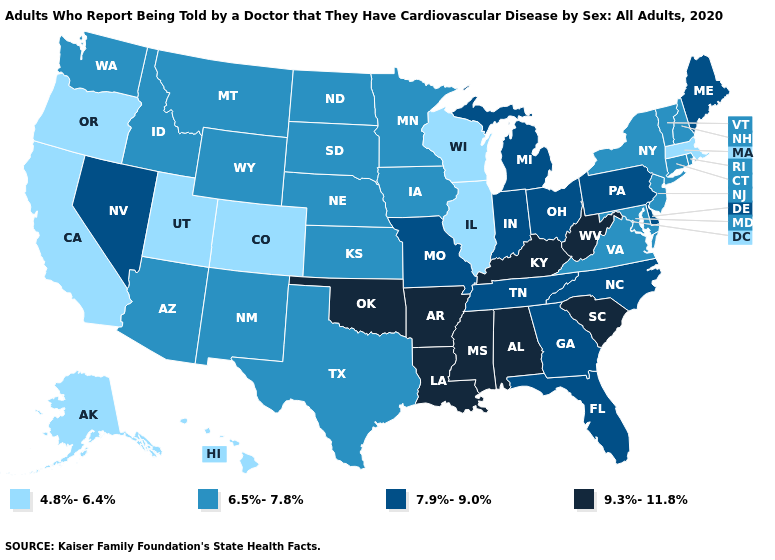What is the value of Delaware?
Write a very short answer. 7.9%-9.0%. Which states hav the highest value in the Northeast?
Write a very short answer. Maine, Pennsylvania. Does Delaware have the same value as Georgia?
Give a very brief answer. Yes. Does the first symbol in the legend represent the smallest category?
Give a very brief answer. Yes. Name the states that have a value in the range 7.9%-9.0%?
Answer briefly. Delaware, Florida, Georgia, Indiana, Maine, Michigan, Missouri, Nevada, North Carolina, Ohio, Pennsylvania, Tennessee. Name the states that have a value in the range 6.5%-7.8%?
Write a very short answer. Arizona, Connecticut, Idaho, Iowa, Kansas, Maryland, Minnesota, Montana, Nebraska, New Hampshire, New Jersey, New Mexico, New York, North Dakota, Rhode Island, South Dakota, Texas, Vermont, Virginia, Washington, Wyoming. Which states have the lowest value in the USA?
Quick response, please. Alaska, California, Colorado, Hawaii, Illinois, Massachusetts, Oregon, Utah, Wisconsin. Does Maine have the same value as New Jersey?
Answer briefly. No. Name the states that have a value in the range 9.3%-11.8%?
Short answer required. Alabama, Arkansas, Kentucky, Louisiana, Mississippi, Oklahoma, South Carolina, West Virginia. Name the states that have a value in the range 6.5%-7.8%?
Short answer required. Arizona, Connecticut, Idaho, Iowa, Kansas, Maryland, Minnesota, Montana, Nebraska, New Hampshire, New Jersey, New Mexico, New York, North Dakota, Rhode Island, South Dakota, Texas, Vermont, Virginia, Washington, Wyoming. What is the highest value in the Northeast ?
Concise answer only. 7.9%-9.0%. Does Alabama have the highest value in the USA?
Write a very short answer. Yes. Name the states that have a value in the range 6.5%-7.8%?
Concise answer only. Arizona, Connecticut, Idaho, Iowa, Kansas, Maryland, Minnesota, Montana, Nebraska, New Hampshire, New Jersey, New Mexico, New York, North Dakota, Rhode Island, South Dakota, Texas, Vermont, Virginia, Washington, Wyoming. What is the lowest value in the USA?
Keep it brief. 4.8%-6.4%. Name the states that have a value in the range 6.5%-7.8%?
Write a very short answer. Arizona, Connecticut, Idaho, Iowa, Kansas, Maryland, Minnesota, Montana, Nebraska, New Hampshire, New Jersey, New Mexico, New York, North Dakota, Rhode Island, South Dakota, Texas, Vermont, Virginia, Washington, Wyoming. 